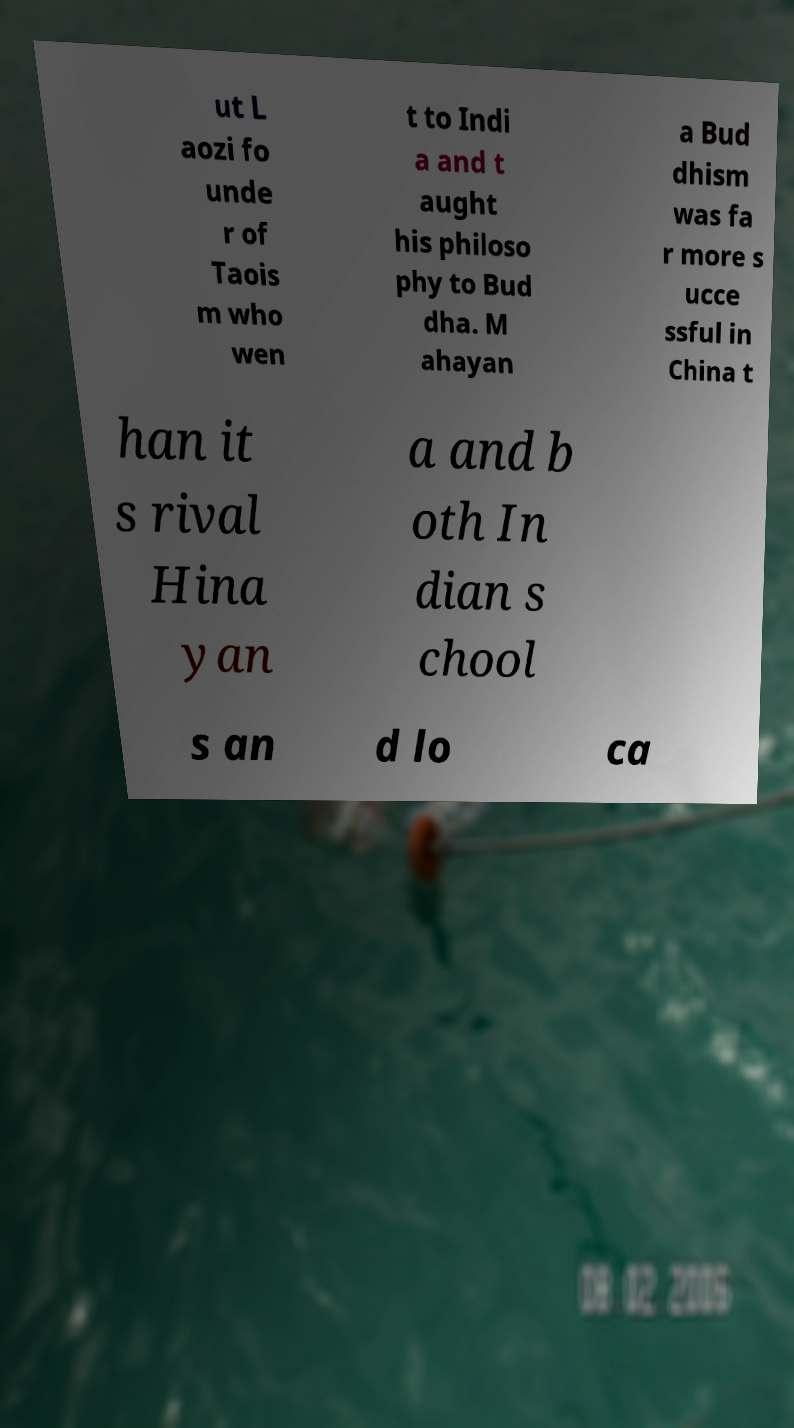There's text embedded in this image that I need extracted. Can you transcribe it verbatim? ut L aozi fo unde r of Taois m who wen t to Indi a and t aught his philoso phy to Bud dha. M ahayan a Bud dhism was fa r more s ucce ssful in China t han it s rival Hina yan a and b oth In dian s chool s an d lo ca 